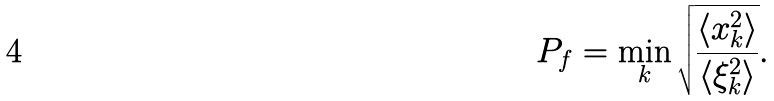<formula> <loc_0><loc_0><loc_500><loc_500>P _ { f } = \min _ { k } \sqrt { \frac { \langle x _ { k } ^ { 2 } \rangle } { \langle \xi _ { k } ^ { 2 } \rangle } } .</formula> 